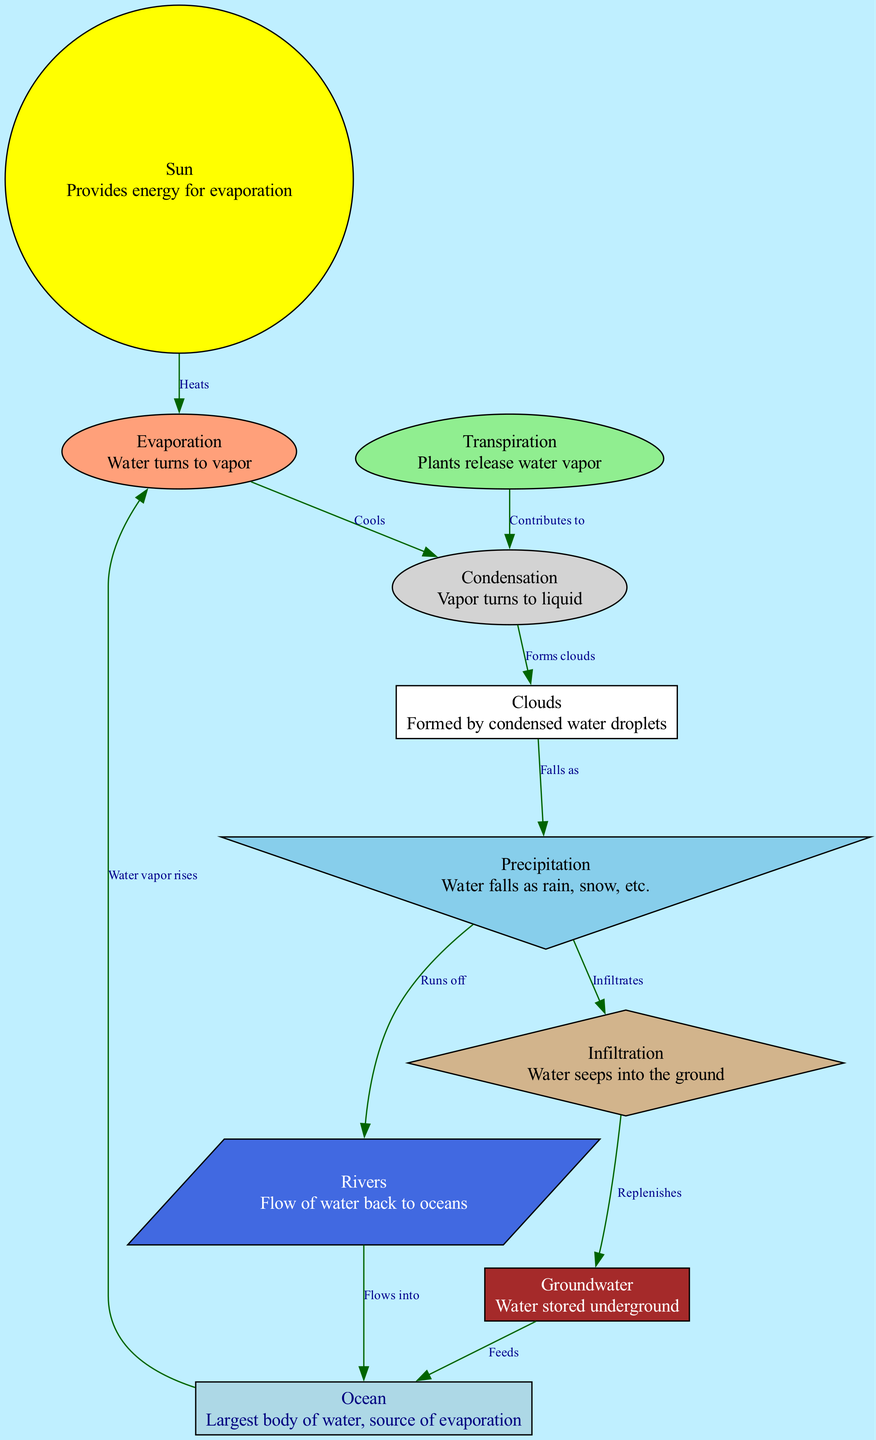What is the main source of evaporation? The diagram shows that the "Ocean" is the largest body of water, which is the main source of evaporation.
Answer: Ocean How many nodes are in the diagram? By counting the "nodes" list in the data, there are 10 distinct nodes depicted in the diagram.
Answer: 10 What process directly follows evaporation? The diagram indicates that "Condensation" occurs immediately after the process of "Evaporation."
Answer: Condensation What falls as precipitation? The diagram describes that "water falls as rain, snow, etc." under the "Precipitation" node, indicating the types of moisture that can fall.
Answer: Water How does water reach the rivers from precipitation? According to the diagram, "Precipitation" leads to "Rivers" through a process referred to as "Runs off."
Answer: Runs off What contributes to condensation from plants? The diagram shows that "Transpiration" by plants contributes to the process of "Condensation," indicating a natural source of vapor.
Answer: Transpiration What does the water in rivers do? The diagram explains that water in "Rivers" flows back to the "Ocean," indicating the movement of water throughout the cycle.
Answer: Flows into Which processes involve movement of water into the ground? The diagram outlines that "Precipitation" leads to "Infiltration," which indicates the process of water seeping into the ground, as shown on the flow chart.
Answer: Infiltration What forms clouds? The flow shows that "Condensation" leads to "Clouds," indicating that clouds are formed from the condensed water droplets.
Answer: Forms clouds How is groundwater replenished? The diagram indicates that "Infiltration" replenishes "Groundwater," demonstrating the process of water re-entering the earth.
Answer: Replenishes 